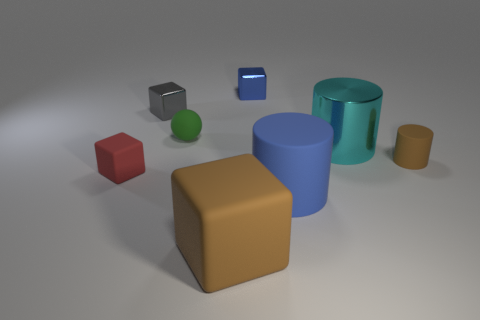Does the green matte object have the same size as the red rubber object?
Offer a terse response. Yes. There is a thing that is both to the right of the small blue thing and in front of the red object; what is its size?
Your answer should be very brief. Large. How many matte objects are either small brown cylinders or tiny blue objects?
Make the answer very short. 1. Is the number of blue metal cubes left of the tiny red block greater than the number of big rubber spheres?
Give a very brief answer. No. What is the material of the blue object that is on the left side of the large matte cylinder?
Ensure brevity in your answer.  Metal. What number of tiny blue blocks have the same material as the large cyan cylinder?
Offer a terse response. 1. What is the shape of the small rubber thing that is in front of the sphere and on the left side of the small blue block?
Offer a very short reply. Cube. How many things are matte things that are behind the tiny matte cylinder or tiny matte objects that are in front of the large cyan metal thing?
Your answer should be compact. 3. Are there an equal number of small metallic blocks in front of the green thing and blue objects that are in front of the big blue object?
Your answer should be very brief. Yes. The brown thing on the left side of the tiny metal cube that is behind the small gray metal object is what shape?
Provide a short and direct response. Cube. 